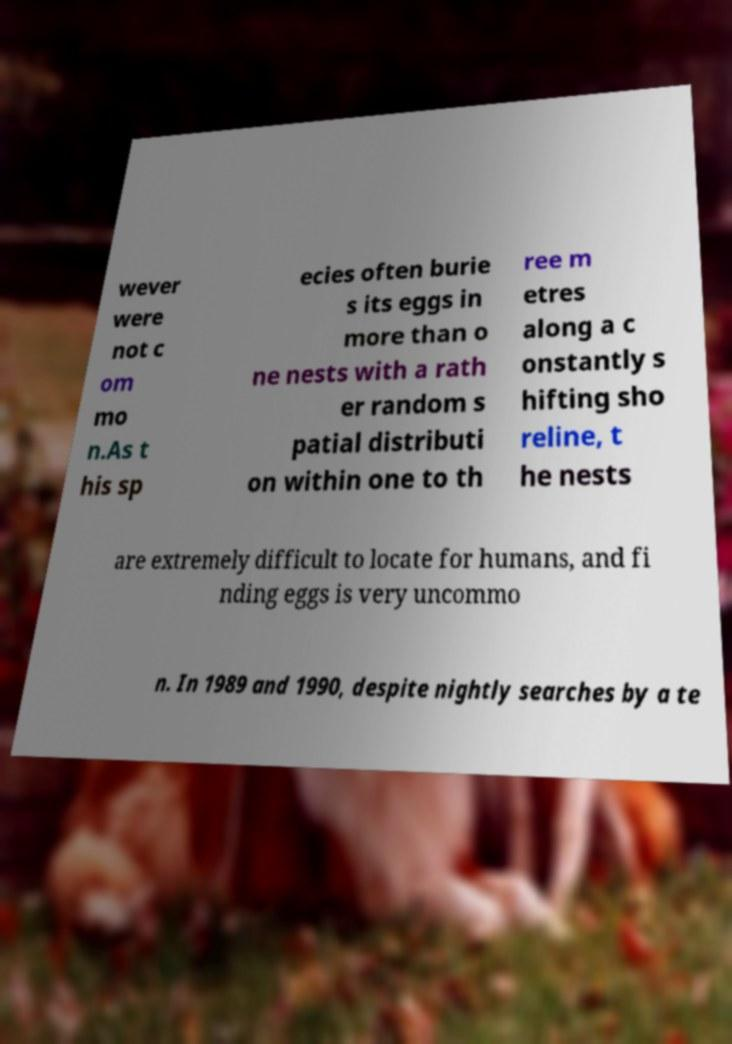Please identify and transcribe the text found in this image. wever were not c om mo n.As t his sp ecies often burie s its eggs in more than o ne nests with a rath er random s patial distributi on within one to th ree m etres along a c onstantly s hifting sho reline, t he nests are extremely difficult to locate for humans, and fi nding eggs is very uncommo n. In 1989 and 1990, despite nightly searches by a te 